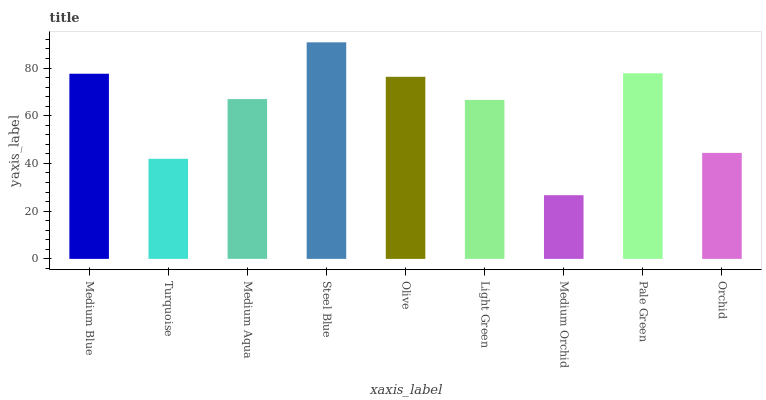Is Medium Orchid the minimum?
Answer yes or no. Yes. Is Steel Blue the maximum?
Answer yes or no. Yes. Is Turquoise the minimum?
Answer yes or no. No. Is Turquoise the maximum?
Answer yes or no. No. Is Medium Blue greater than Turquoise?
Answer yes or no. Yes. Is Turquoise less than Medium Blue?
Answer yes or no. Yes. Is Turquoise greater than Medium Blue?
Answer yes or no. No. Is Medium Blue less than Turquoise?
Answer yes or no. No. Is Medium Aqua the high median?
Answer yes or no. Yes. Is Medium Aqua the low median?
Answer yes or no. Yes. Is Medium Blue the high median?
Answer yes or no. No. Is Turquoise the low median?
Answer yes or no. No. 